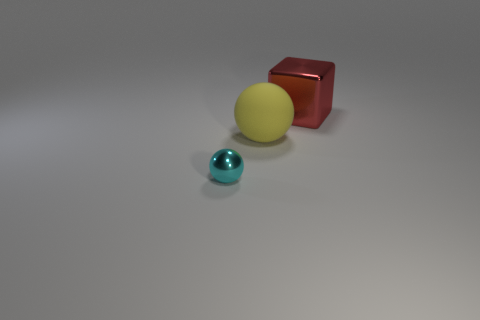Is the tiny cyan shiny thing the same shape as the yellow object?
Make the answer very short. Yes. How big is the object behind the rubber object?
Provide a short and direct response. Large. There is another red thing that is made of the same material as the tiny object; what size is it?
Keep it short and to the point. Large. Are there fewer large matte balls than cyan matte cylinders?
Make the answer very short. No. There is a red cube that is the same size as the matte thing; what is it made of?
Your response must be concise. Metal. Are there more balls than small green rubber cylinders?
Your answer should be compact. Yes. What number of other things are there of the same color as the block?
Offer a terse response. 0. How many objects are both behind the cyan metal thing and on the left side of the red block?
Offer a terse response. 1. Is there any other thing that is the same size as the yellow ball?
Make the answer very short. Yes. Are there more big yellow objects that are behind the yellow rubber object than large rubber objects that are behind the red metallic object?
Your answer should be compact. No. 